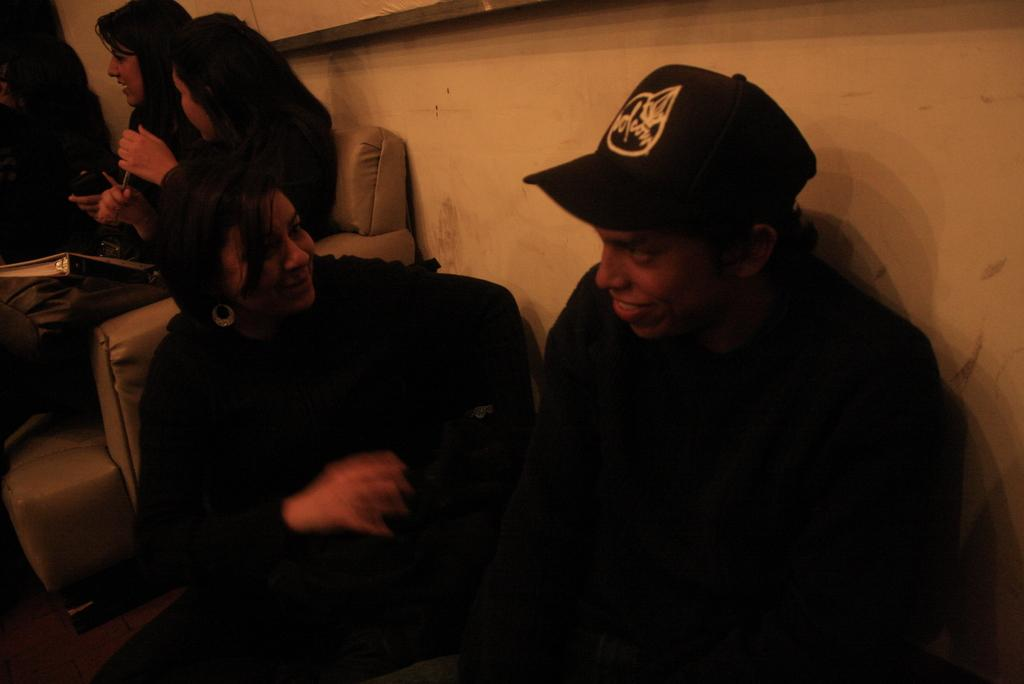Who or what is present in the image? There are people in the image. What are the people doing in the image? The people are sitting on chairs. What can be seen in the background of the image? There is a wall in the background of the image. How many geese are sitting on the sofa in the image? There are no geese or sofa present in the image. What type of tooth is visible in the image? There is no tooth visible in the image. 